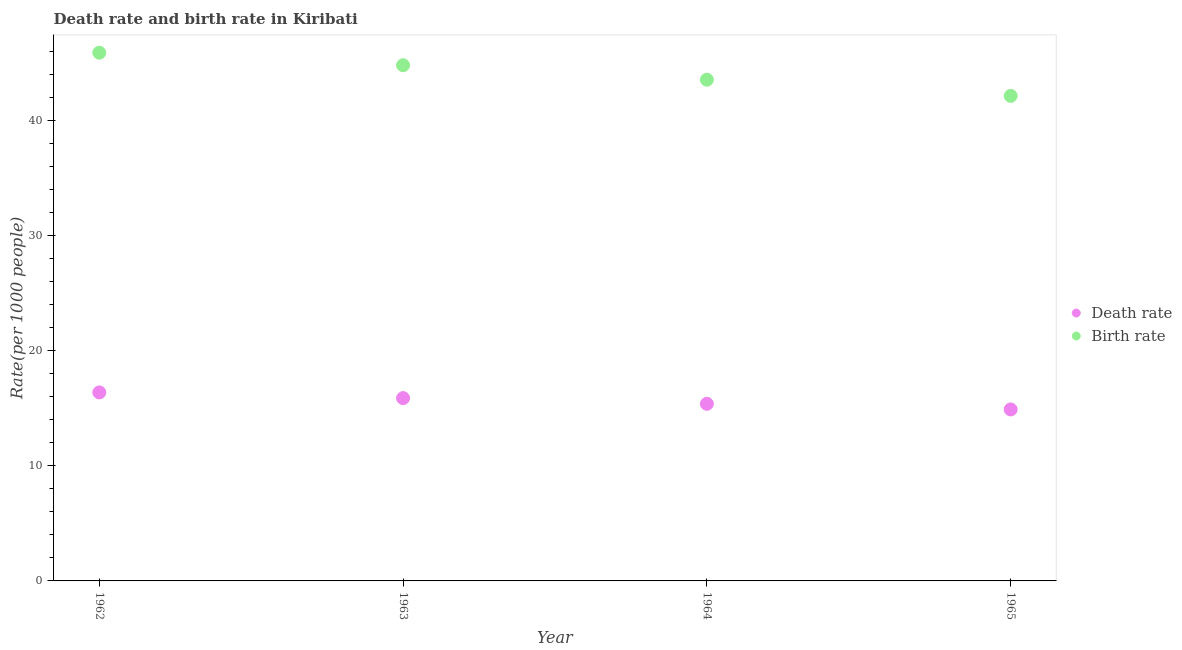How many different coloured dotlines are there?
Make the answer very short. 2. What is the death rate in 1964?
Give a very brief answer. 15.39. Across all years, what is the maximum birth rate?
Provide a succinct answer. 45.91. Across all years, what is the minimum birth rate?
Your response must be concise. 42.15. In which year was the death rate minimum?
Make the answer very short. 1965. What is the total birth rate in the graph?
Offer a very short reply. 176.44. What is the difference between the birth rate in 1962 and that in 1965?
Make the answer very short. 3.75. What is the difference between the death rate in 1963 and the birth rate in 1962?
Ensure brevity in your answer.  -30.02. What is the average death rate per year?
Offer a very short reply. 15.64. In the year 1963, what is the difference between the birth rate and death rate?
Your response must be concise. 28.93. In how many years, is the death rate greater than 44?
Your answer should be very brief. 0. What is the ratio of the birth rate in 1964 to that in 1965?
Provide a succinct answer. 1.03. Is the birth rate in 1962 less than that in 1965?
Your response must be concise. No. Is the difference between the birth rate in 1963 and 1964 greater than the difference between the death rate in 1963 and 1964?
Your response must be concise. Yes. What is the difference between the highest and the second highest death rate?
Provide a short and direct response. 0.5. What is the difference between the highest and the lowest death rate?
Offer a terse response. 1.48. Is the death rate strictly greater than the birth rate over the years?
Your answer should be compact. No. Is the death rate strictly less than the birth rate over the years?
Provide a succinct answer. Yes. How many dotlines are there?
Offer a very short reply. 2. Where does the legend appear in the graph?
Provide a succinct answer. Center right. How many legend labels are there?
Your answer should be compact. 2. How are the legend labels stacked?
Your response must be concise. Vertical. What is the title of the graph?
Provide a succinct answer. Death rate and birth rate in Kiribati. What is the label or title of the Y-axis?
Give a very brief answer. Rate(per 1000 people). What is the Rate(per 1000 people) of Death rate in 1962?
Provide a succinct answer. 16.38. What is the Rate(per 1000 people) of Birth rate in 1962?
Give a very brief answer. 45.91. What is the Rate(per 1000 people) of Death rate in 1963?
Your answer should be compact. 15.89. What is the Rate(per 1000 people) in Birth rate in 1963?
Your answer should be compact. 44.82. What is the Rate(per 1000 people) of Death rate in 1964?
Provide a short and direct response. 15.39. What is the Rate(per 1000 people) of Birth rate in 1964?
Keep it short and to the point. 43.56. What is the Rate(per 1000 people) of Death rate in 1965?
Your answer should be very brief. 14.9. What is the Rate(per 1000 people) in Birth rate in 1965?
Your answer should be very brief. 42.15. Across all years, what is the maximum Rate(per 1000 people) in Death rate?
Your response must be concise. 16.38. Across all years, what is the maximum Rate(per 1000 people) in Birth rate?
Provide a succinct answer. 45.91. Across all years, what is the minimum Rate(per 1000 people) of Death rate?
Your answer should be compact. 14.9. Across all years, what is the minimum Rate(per 1000 people) of Birth rate?
Make the answer very short. 42.15. What is the total Rate(per 1000 people) in Death rate in the graph?
Your answer should be very brief. 62.57. What is the total Rate(per 1000 people) of Birth rate in the graph?
Your answer should be very brief. 176.44. What is the difference between the Rate(per 1000 people) in Death rate in 1962 and that in 1963?
Offer a very short reply. 0.5. What is the difference between the Rate(per 1000 people) in Birth rate in 1962 and that in 1963?
Ensure brevity in your answer.  1.09. What is the difference between the Rate(per 1000 people) in Birth rate in 1962 and that in 1964?
Ensure brevity in your answer.  2.35. What is the difference between the Rate(per 1000 people) of Death rate in 1962 and that in 1965?
Offer a very short reply. 1.48. What is the difference between the Rate(per 1000 people) in Birth rate in 1962 and that in 1965?
Make the answer very short. 3.75. What is the difference between the Rate(per 1000 people) in Death rate in 1963 and that in 1964?
Provide a succinct answer. 0.49. What is the difference between the Rate(per 1000 people) in Birth rate in 1963 and that in 1964?
Your answer should be very brief. 1.26. What is the difference between the Rate(per 1000 people) in Birth rate in 1963 and that in 1965?
Give a very brief answer. 2.66. What is the difference between the Rate(per 1000 people) in Death rate in 1964 and that in 1965?
Offer a very short reply. 0.49. What is the difference between the Rate(per 1000 people) in Birth rate in 1964 and that in 1965?
Keep it short and to the point. 1.41. What is the difference between the Rate(per 1000 people) of Death rate in 1962 and the Rate(per 1000 people) of Birth rate in 1963?
Your answer should be compact. -28.43. What is the difference between the Rate(per 1000 people) in Death rate in 1962 and the Rate(per 1000 people) in Birth rate in 1964?
Ensure brevity in your answer.  -27.18. What is the difference between the Rate(per 1000 people) of Death rate in 1962 and the Rate(per 1000 people) of Birth rate in 1965?
Your response must be concise. -25.77. What is the difference between the Rate(per 1000 people) of Death rate in 1963 and the Rate(per 1000 people) of Birth rate in 1964?
Give a very brief answer. -27.67. What is the difference between the Rate(per 1000 people) in Death rate in 1963 and the Rate(per 1000 people) in Birth rate in 1965?
Provide a short and direct response. -26.27. What is the difference between the Rate(per 1000 people) in Death rate in 1964 and the Rate(per 1000 people) in Birth rate in 1965?
Offer a very short reply. -26.76. What is the average Rate(per 1000 people) of Death rate per year?
Your answer should be very brief. 15.64. What is the average Rate(per 1000 people) of Birth rate per year?
Your response must be concise. 44.11. In the year 1962, what is the difference between the Rate(per 1000 people) in Death rate and Rate(per 1000 people) in Birth rate?
Give a very brief answer. -29.52. In the year 1963, what is the difference between the Rate(per 1000 people) in Death rate and Rate(per 1000 people) in Birth rate?
Your answer should be very brief. -28.93. In the year 1964, what is the difference between the Rate(per 1000 people) in Death rate and Rate(per 1000 people) in Birth rate?
Your answer should be very brief. -28.17. In the year 1965, what is the difference between the Rate(per 1000 people) in Death rate and Rate(per 1000 people) in Birth rate?
Provide a succinct answer. -27.25. What is the ratio of the Rate(per 1000 people) in Death rate in 1962 to that in 1963?
Ensure brevity in your answer.  1.03. What is the ratio of the Rate(per 1000 people) of Birth rate in 1962 to that in 1963?
Give a very brief answer. 1.02. What is the ratio of the Rate(per 1000 people) in Death rate in 1962 to that in 1964?
Your response must be concise. 1.06. What is the ratio of the Rate(per 1000 people) in Birth rate in 1962 to that in 1964?
Make the answer very short. 1.05. What is the ratio of the Rate(per 1000 people) in Death rate in 1962 to that in 1965?
Ensure brevity in your answer.  1.1. What is the ratio of the Rate(per 1000 people) in Birth rate in 1962 to that in 1965?
Give a very brief answer. 1.09. What is the ratio of the Rate(per 1000 people) in Death rate in 1963 to that in 1964?
Offer a very short reply. 1.03. What is the ratio of the Rate(per 1000 people) of Birth rate in 1963 to that in 1964?
Offer a terse response. 1.03. What is the ratio of the Rate(per 1000 people) of Death rate in 1963 to that in 1965?
Your response must be concise. 1.07. What is the ratio of the Rate(per 1000 people) in Birth rate in 1963 to that in 1965?
Offer a very short reply. 1.06. What is the ratio of the Rate(per 1000 people) in Death rate in 1964 to that in 1965?
Your answer should be very brief. 1.03. What is the ratio of the Rate(per 1000 people) in Birth rate in 1964 to that in 1965?
Provide a succinct answer. 1.03. What is the difference between the highest and the second highest Rate(per 1000 people) in Death rate?
Offer a very short reply. 0.5. What is the difference between the highest and the second highest Rate(per 1000 people) of Birth rate?
Give a very brief answer. 1.09. What is the difference between the highest and the lowest Rate(per 1000 people) in Death rate?
Provide a short and direct response. 1.48. What is the difference between the highest and the lowest Rate(per 1000 people) in Birth rate?
Ensure brevity in your answer.  3.75. 